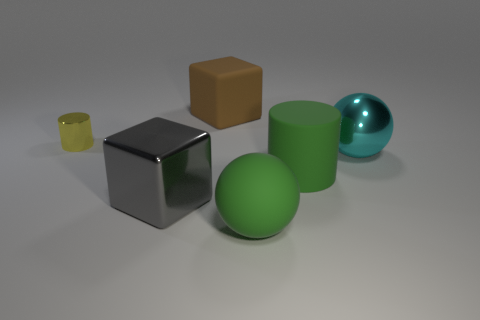Add 1 rubber blocks. How many objects exist? 7 Subtract all balls. How many objects are left? 4 Subtract 0 red spheres. How many objects are left? 6 Subtract all small shiny things. Subtract all large metal blocks. How many objects are left? 4 Add 1 blocks. How many blocks are left? 3 Add 2 green spheres. How many green spheres exist? 3 